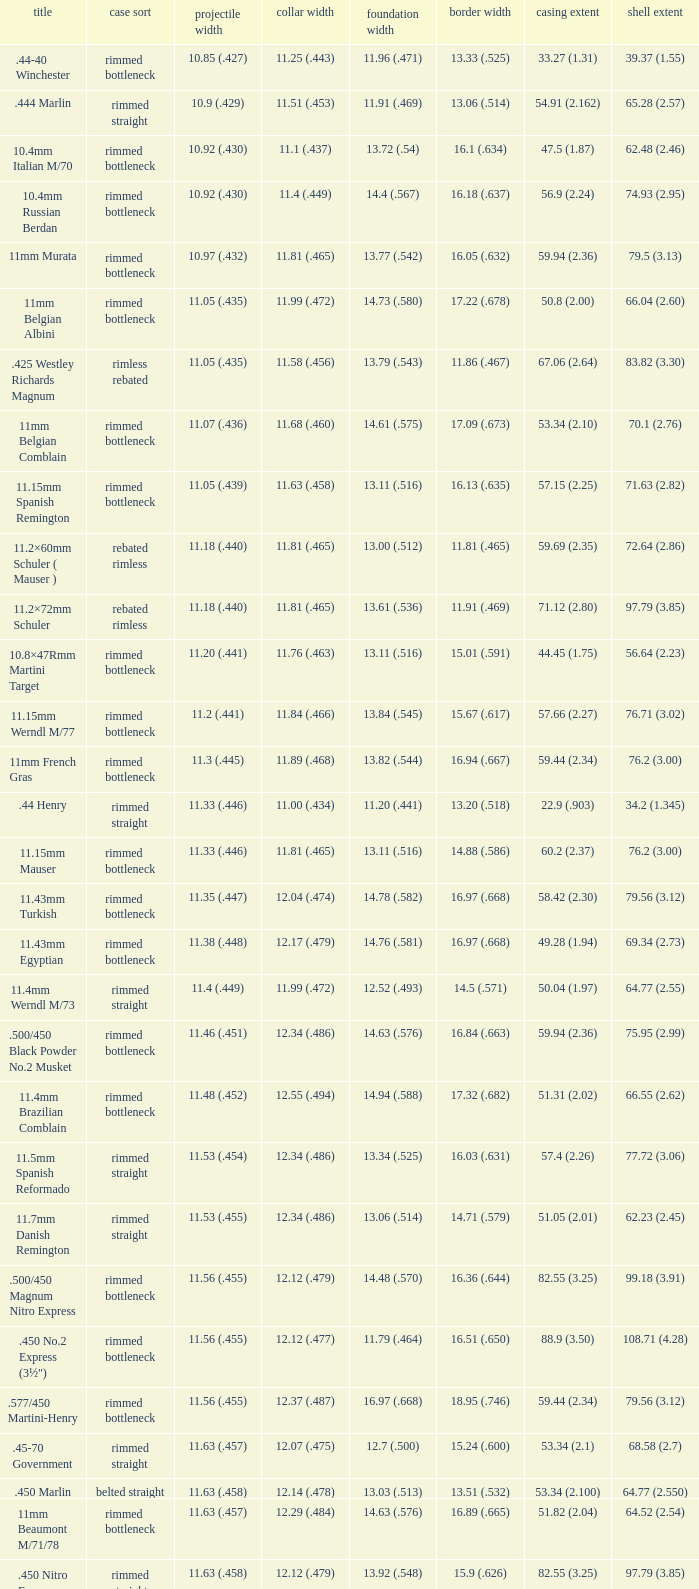Which Bullet diameter has a Neck diameter of 12.17 (.479)? 11.38 (.448). 